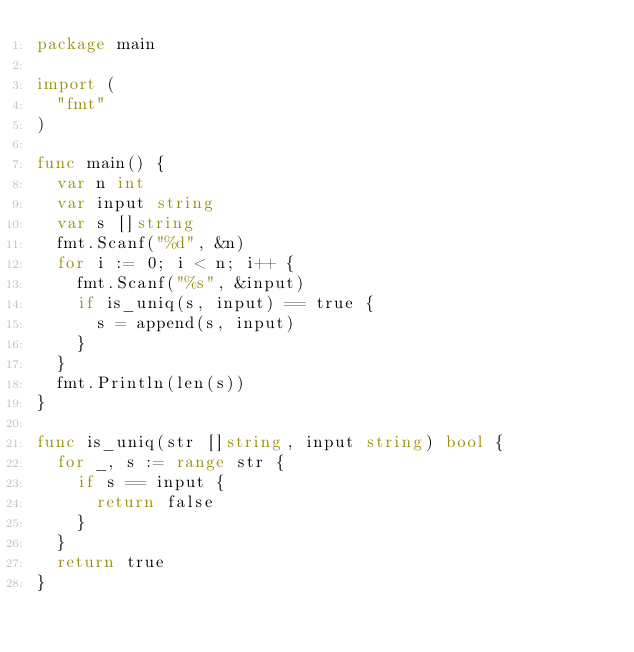<code> <loc_0><loc_0><loc_500><loc_500><_Go_>package main

import (
	"fmt"
)

func main() {
	var n int
	var input string
	var s []string
	fmt.Scanf("%d", &n)
	for i := 0; i < n; i++ {
		fmt.Scanf("%s", &input)
		if is_uniq(s, input) == true {
			s = append(s, input)
		}
	}
	fmt.Println(len(s))
}

func is_uniq(str []string, input string) bool {
	for _, s := range str {
		if s == input {
			return false
		}
	}
	return true
}
</code> 